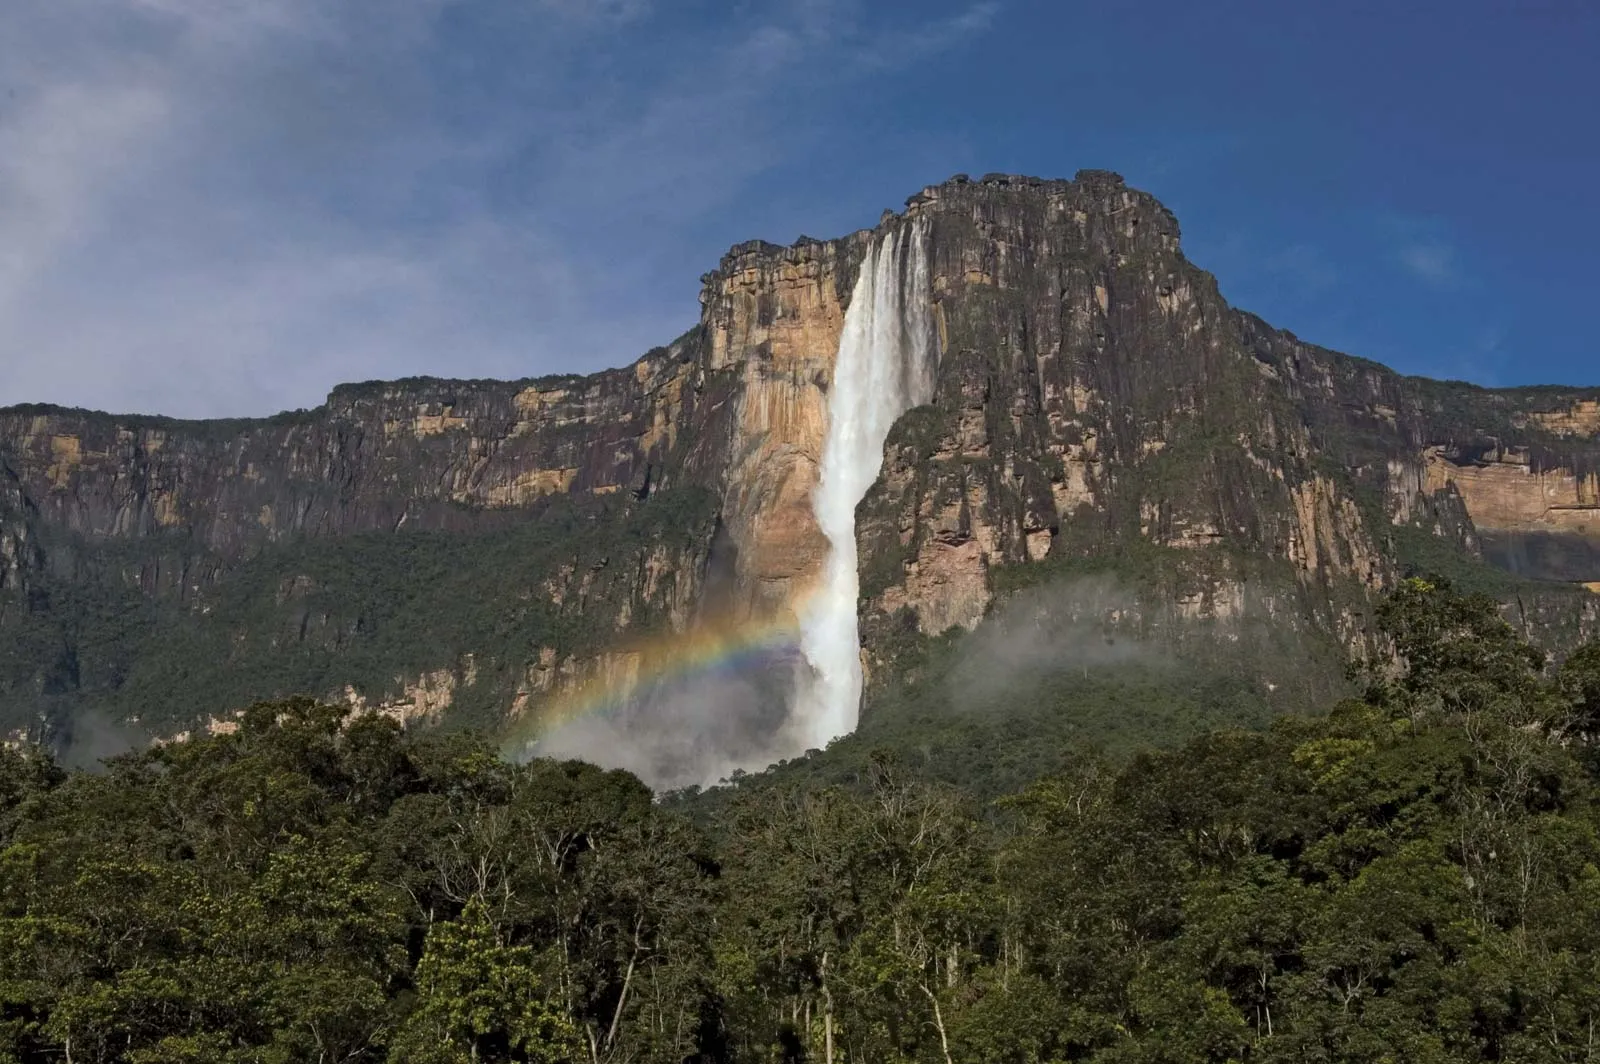What is this photo about? This image showcases the awe-inspiring Angel Falls, acclaimed as the highest uninterrupted waterfall in the world, situated in Venezuela. The waterfall is dramatically pouring over a towering cliff, creating an entrancing display as the water plummets into a misty spray. At the base of the falls, the sunlight interacting with the mist forms a delicate rainbow, adding to the enchanting atmosphere. The verdant green foliage covering the cliff enhances the natural beauty, sharply contrasting with the azure sky scattered with a few clouds. The distant perspective of the photograph allows us to appreciate not only the grandeur of the waterfall but also the extensive landscape that surrounds it. This image magnificently captures the untamed and unspoiled splendor of Angel Falls. 